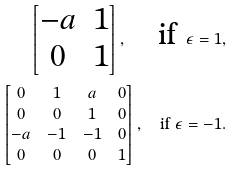Convert formula to latex. <formula><loc_0><loc_0><loc_500><loc_500>\begin{bmatrix} - a & 1 \\ 0 & 1 \end{bmatrix} , \quad \text {if } \epsilon = 1 , \\ \begin{bmatrix} 0 & 1 & a & 0 \\ 0 & 0 & 1 & 0 \\ - a & - 1 & - 1 & 0 \\ 0 & 0 & 0 & 1 \end{bmatrix} , \quad \text {if } \epsilon = - 1 .</formula> 